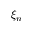Convert formula to latex. <formula><loc_0><loc_0><loc_500><loc_500>\xi _ { n }</formula> 